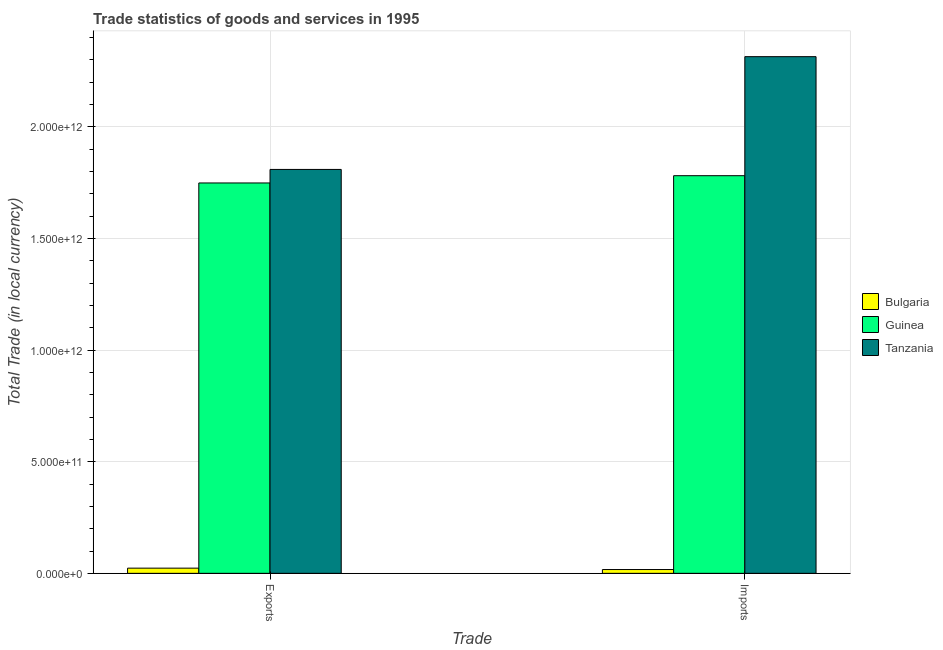How many different coloured bars are there?
Provide a succinct answer. 3. How many bars are there on the 2nd tick from the left?
Ensure brevity in your answer.  3. How many bars are there on the 1st tick from the right?
Keep it short and to the point. 3. What is the label of the 1st group of bars from the left?
Your answer should be compact. Exports. What is the export of goods and services in Guinea?
Provide a succinct answer. 1.75e+12. Across all countries, what is the maximum imports of goods and services?
Give a very brief answer. 2.31e+12. Across all countries, what is the minimum imports of goods and services?
Your response must be concise. 1.70e+1. In which country was the imports of goods and services maximum?
Make the answer very short. Tanzania. What is the total imports of goods and services in the graph?
Make the answer very short. 4.11e+12. What is the difference between the imports of goods and services in Tanzania and that in Bulgaria?
Provide a short and direct response. 2.30e+12. What is the difference between the export of goods and services in Bulgaria and the imports of goods and services in Tanzania?
Your answer should be very brief. -2.29e+12. What is the average imports of goods and services per country?
Provide a short and direct response. 1.37e+12. What is the difference between the export of goods and services and imports of goods and services in Tanzania?
Your response must be concise. -5.05e+11. What is the ratio of the export of goods and services in Bulgaria to that in Guinea?
Your answer should be compact. 0.01. In how many countries, is the export of goods and services greater than the average export of goods and services taken over all countries?
Your answer should be very brief. 2. What does the 3rd bar from the left in Imports represents?
Ensure brevity in your answer.  Tanzania. What does the 1st bar from the right in Exports represents?
Offer a terse response. Tanzania. Are all the bars in the graph horizontal?
Your response must be concise. No. How many countries are there in the graph?
Your answer should be compact. 3. What is the difference between two consecutive major ticks on the Y-axis?
Provide a short and direct response. 5.00e+11. Are the values on the major ticks of Y-axis written in scientific E-notation?
Offer a terse response. Yes. Does the graph contain any zero values?
Offer a terse response. No. Does the graph contain grids?
Ensure brevity in your answer.  Yes. Where does the legend appear in the graph?
Give a very brief answer. Center right. How are the legend labels stacked?
Offer a terse response. Vertical. What is the title of the graph?
Your answer should be compact. Trade statistics of goods and services in 1995. Does "Romania" appear as one of the legend labels in the graph?
Ensure brevity in your answer.  No. What is the label or title of the X-axis?
Offer a very short reply. Trade. What is the label or title of the Y-axis?
Provide a short and direct response. Total Trade (in local currency). What is the Total Trade (in local currency) in Bulgaria in Exports?
Make the answer very short. 2.32e+1. What is the Total Trade (in local currency) of Guinea in Exports?
Your answer should be compact. 1.75e+12. What is the Total Trade (in local currency) in Tanzania in Exports?
Give a very brief answer. 1.81e+12. What is the Total Trade (in local currency) in Bulgaria in Imports?
Your response must be concise. 1.70e+1. What is the Total Trade (in local currency) of Guinea in Imports?
Ensure brevity in your answer.  1.78e+12. What is the Total Trade (in local currency) of Tanzania in Imports?
Your answer should be compact. 2.31e+12. Across all Trade, what is the maximum Total Trade (in local currency) of Bulgaria?
Offer a terse response. 2.32e+1. Across all Trade, what is the maximum Total Trade (in local currency) of Guinea?
Ensure brevity in your answer.  1.78e+12. Across all Trade, what is the maximum Total Trade (in local currency) of Tanzania?
Give a very brief answer. 2.31e+12. Across all Trade, what is the minimum Total Trade (in local currency) in Bulgaria?
Provide a short and direct response. 1.70e+1. Across all Trade, what is the minimum Total Trade (in local currency) of Guinea?
Keep it short and to the point. 1.75e+12. Across all Trade, what is the minimum Total Trade (in local currency) of Tanzania?
Provide a succinct answer. 1.81e+12. What is the total Total Trade (in local currency) of Bulgaria in the graph?
Offer a terse response. 4.03e+1. What is the total Total Trade (in local currency) in Guinea in the graph?
Offer a terse response. 3.53e+12. What is the total Total Trade (in local currency) in Tanzania in the graph?
Provide a short and direct response. 4.12e+12. What is the difference between the Total Trade (in local currency) in Bulgaria in Exports and that in Imports?
Make the answer very short. 6.23e+09. What is the difference between the Total Trade (in local currency) in Guinea in Exports and that in Imports?
Give a very brief answer. -3.25e+1. What is the difference between the Total Trade (in local currency) of Tanzania in Exports and that in Imports?
Provide a short and direct response. -5.05e+11. What is the difference between the Total Trade (in local currency) of Bulgaria in Exports and the Total Trade (in local currency) of Guinea in Imports?
Offer a terse response. -1.76e+12. What is the difference between the Total Trade (in local currency) in Bulgaria in Exports and the Total Trade (in local currency) in Tanzania in Imports?
Your answer should be compact. -2.29e+12. What is the difference between the Total Trade (in local currency) of Guinea in Exports and the Total Trade (in local currency) of Tanzania in Imports?
Offer a terse response. -5.66e+11. What is the average Total Trade (in local currency) in Bulgaria per Trade?
Provide a succinct answer. 2.01e+1. What is the average Total Trade (in local currency) in Guinea per Trade?
Offer a very short reply. 1.77e+12. What is the average Total Trade (in local currency) in Tanzania per Trade?
Ensure brevity in your answer.  2.06e+12. What is the difference between the Total Trade (in local currency) of Bulgaria and Total Trade (in local currency) of Guinea in Exports?
Your answer should be compact. -1.73e+12. What is the difference between the Total Trade (in local currency) in Bulgaria and Total Trade (in local currency) in Tanzania in Exports?
Provide a short and direct response. -1.79e+12. What is the difference between the Total Trade (in local currency) in Guinea and Total Trade (in local currency) in Tanzania in Exports?
Offer a terse response. -6.06e+1. What is the difference between the Total Trade (in local currency) of Bulgaria and Total Trade (in local currency) of Guinea in Imports?
Make the answer very short. -1.76e+12. What is the difference between the Total Trade (in local currency) of Bulgaria and Total Trade (in local currency) of Tanzania in Imports?
Offer a terse response. -2.30e+12. What is the difference between the Total Trade (in local currency) of Guinea and Total Trade (in local currency) of Tanzania in Imports?
Offer a terse response. -5.33e+11. What is the ratio of the Total Trade (in local currency) in Bulgaria in Exports to that in Imports?
Make the answer very short. 1.37. What is the ratio of the Total Trade (in local currency) of Guinea in Exports to that in Imports?
Your answer should be very brief. 0.98. What is the ratio of the Total Trade (in local currency) in Tanzania in Exports to that in Imports?
Ensure brevity in your answer.  0.78. What is the difference between the highest and the second highest Total Trade (in local currency) in Bulgaria?
Your answer should be compact. 6.23e+09. What is the difference between the highest and the second highest Total Trade (in local currency) of Guinea?
Keep it short and to the point. 3.25e+1. What is the difference between the highest and the second highest Total Trade (in local currency) of Tanzania?
Keep it short and to the point. 5.05e+11. What is the difference between the highest and the lowest Total Trade (in local currency) in Bulgaria?
Provide a short and direct response. 6.23e+09. What is the difference between the highest and the lowest Total Trade (in local currency) of Guinea?
Your response must be concise. 3.25e+1. What is the difference between the highest and the lowest Total Trade (in local currency) of Tanzania?
Keep it short and to the point. 5.05e+11. 